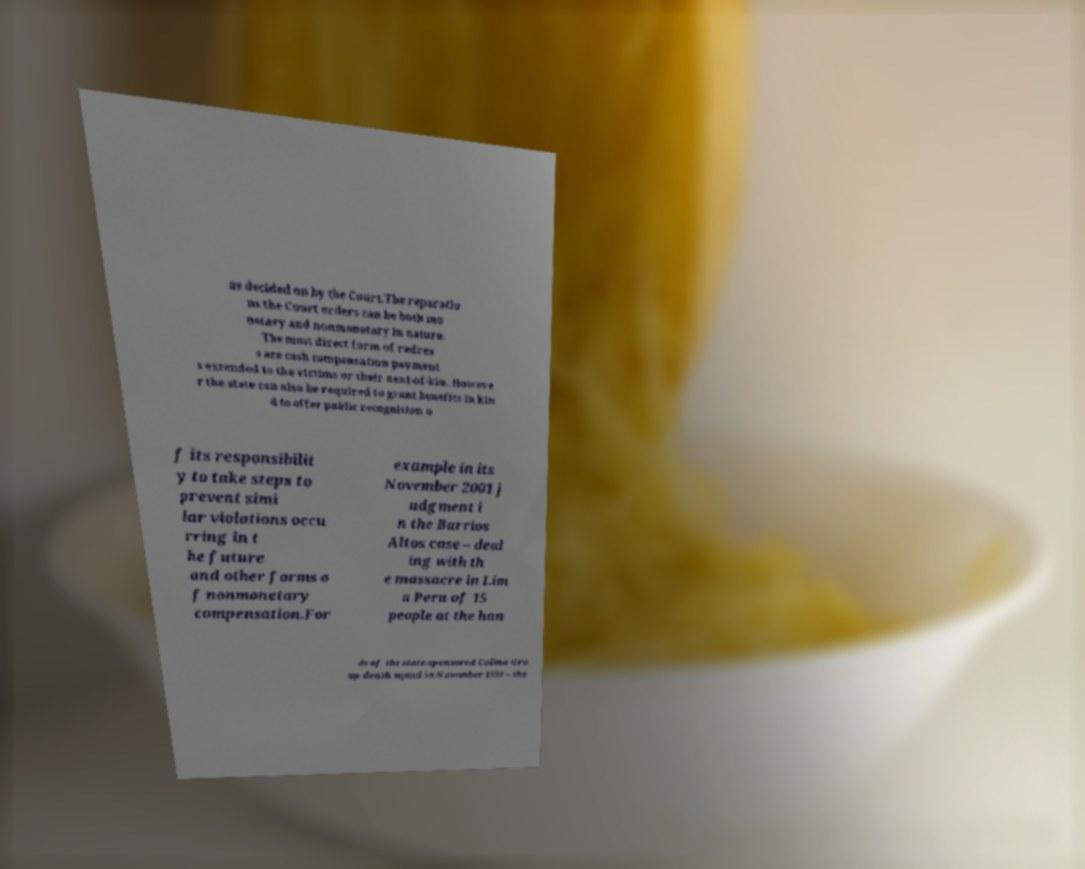Can you read and provide the text displayed in the image?This photo seems to have some interesting text. Can you extract and type it out for me? as decided on by the Court.The reparatio ns the Court orders can be both mo netary and nonmonetary in nature. The most direct form of redres s are cash compensation payment s extended to the victims or their next-of-kin. Howeve r the state can also be required to grant benefits in kin d to offer public recognition o f its responsibilit y to take steps to prevent simi lar violations occu rring in t he future and other forms o f nonmonetary compensation.For example in its November 2001 j udgment i n the Barrios Altos case – deal ing with th e massacre in Lim a Peru of 15 people at the han ds of the state-sponsored Colina Gro up death squad in November 1991 – the 